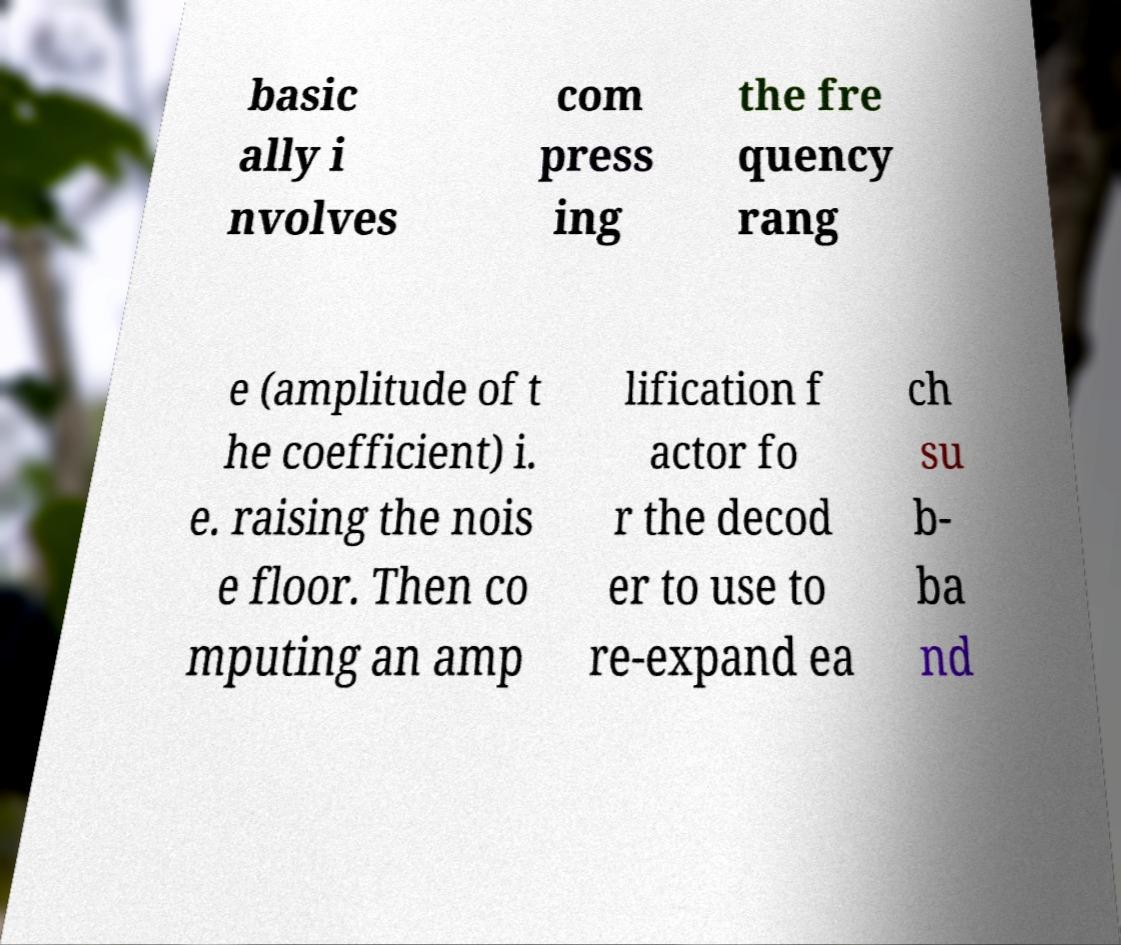Can you accurately transcribe the text from the provided image for me? basic ally i nvolves com press ing the fre quency rang e (amplitude of t he coefficient) i. e. raising the nois e floor. Then co mputing an amp lification f actor fo r the decod er to use to re-expand ea ch su b- ba nd 